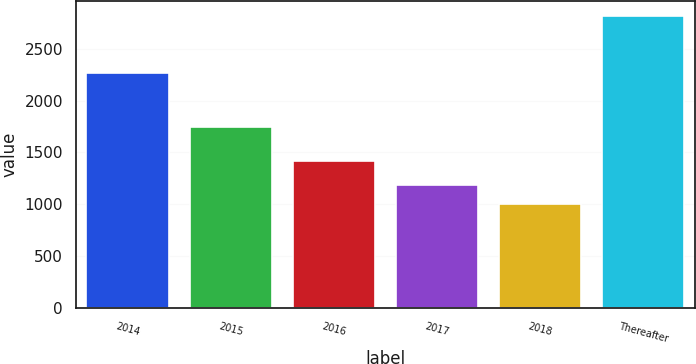Convert chart to OTSL. <chart><loc_0><loc_0><loc_500><loc_500><bar_chart><fcel>2014<fcel>2015<fcel>2016<fcel>2017<fcel>2018<fcel>Thereafter<nl><fcel>2265<fcel>1741<fcel>1419<fcel>1187.9<fcel>1007<fcel>2816<nl></chart> 